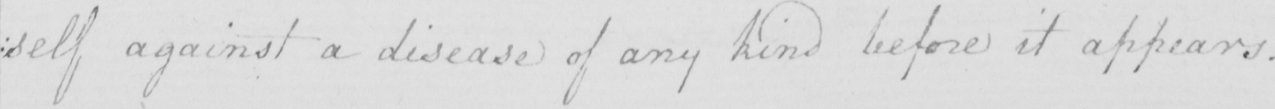Can you read and transcribe this handwriting? self against a disease of any kind before it appears . 